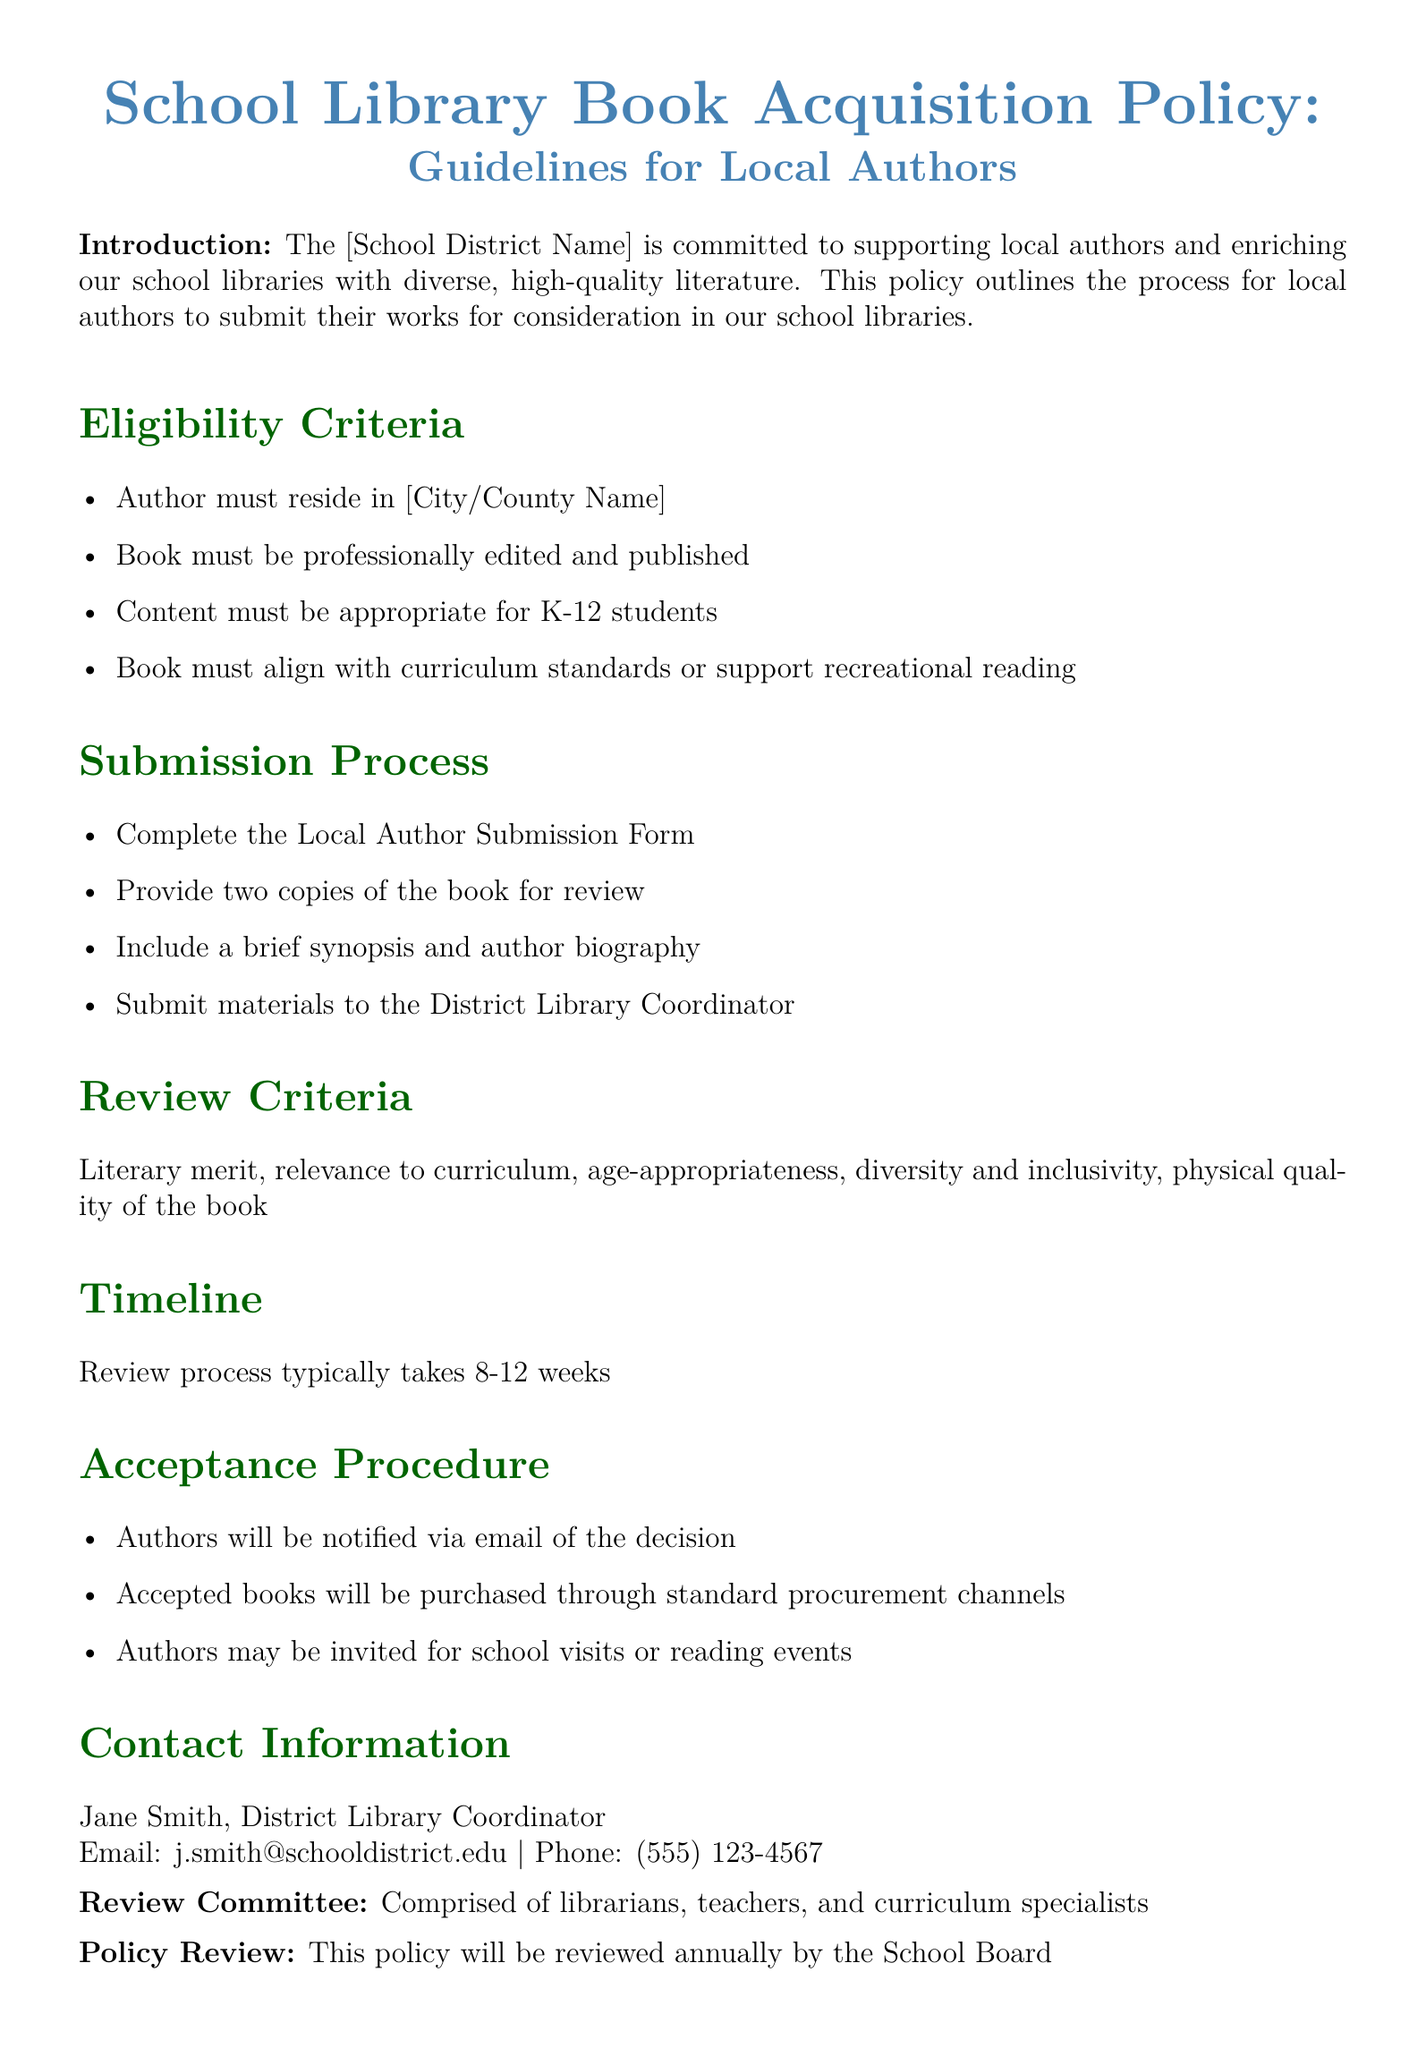What is the primary goal of the policy? The primary goal is to support local authors and enrich school libraries with diverse literature.
Answer: support local authors and enrich school libraries Who should the author contact for submissions? The document specifies that the submissions should be directed to the District Library Coordinator.
Answer: District Library Coordinator What is the minimum review time for submissions? The review process typically takes 8-12 weeks, indicating the minimum review time required for submissions.
Answer: 8-12 weeks What format must the submission be in? The document states that authors must provide two copies of the book for review, indicating the physical format required.
Answer: two copies What criteria must the book align with? The book must align with curriculum standards or support recreational reading, as stated in the eligibility section.
Answer: curriculum standards or recreational reading How many copies of the book are required for submission? The document indicates that two copies must be provided for review.
Answer: two copies What type of committee reviews the submissions? The review committee is comprised of librarians, teachers, and curriculum specialists.
Answer: librarians, teachers, and curriculum specialists What should be included along with the book submission? The author must include a brief synopsis and author biography along with their book.
Answer: brief synopsis and author biography 